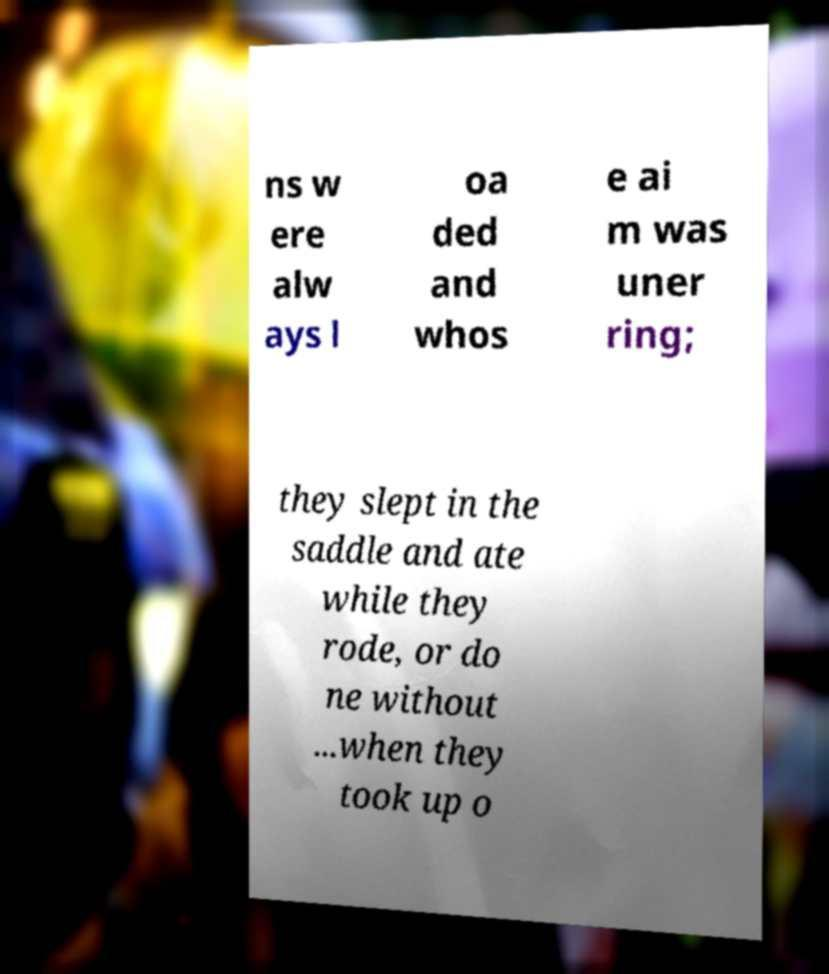Can you accurately transcribe the text from the provided image for me? ns w ere alw ays l oa ded and whos e ai m was uner ring; they slept in the saddle and ate while they rode, or do ne without ...when they took up o 